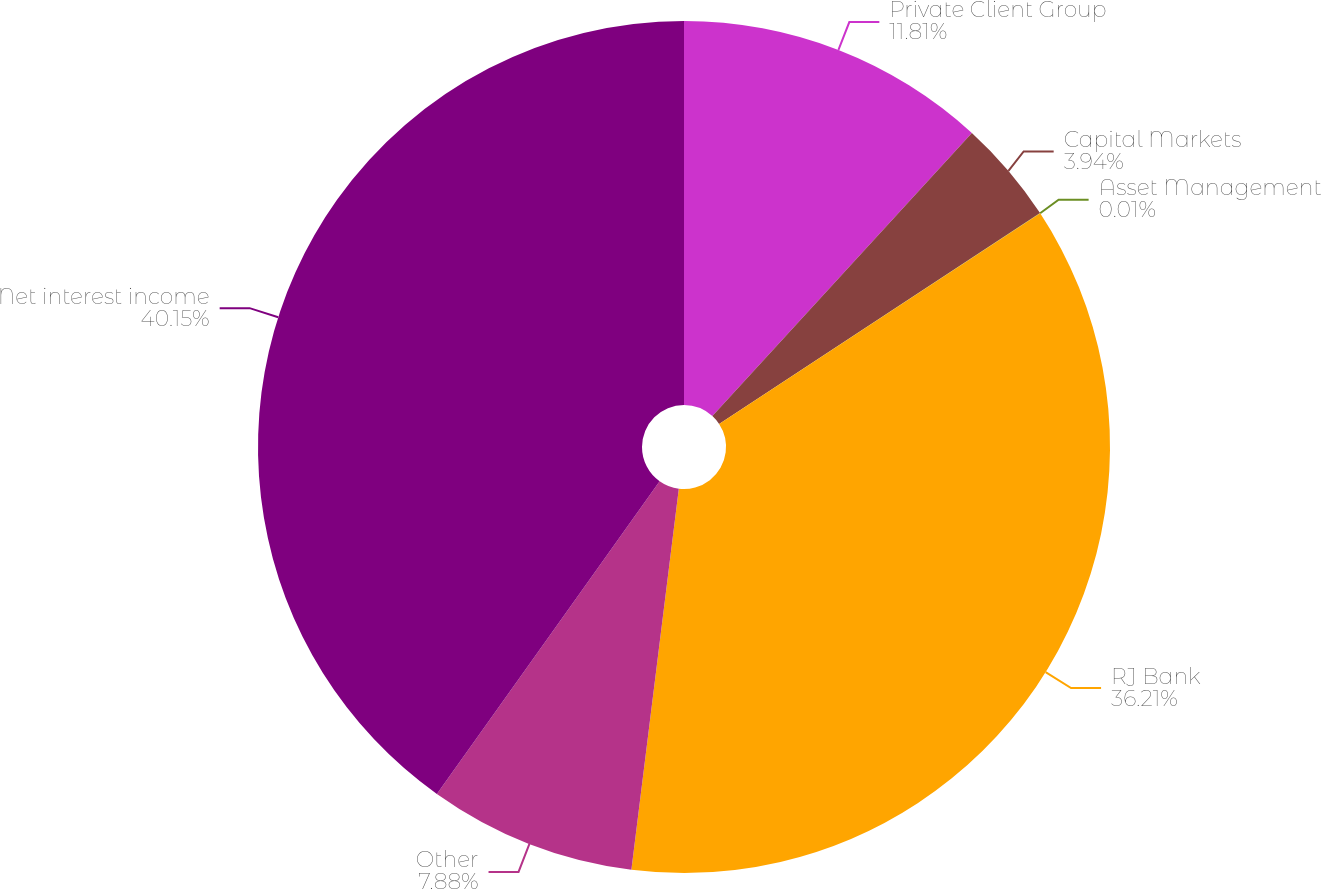Convert chart. <chart><loc_0><loc_0><loc_500><loc_500><pie_chart><fcel>Private Client Group<fcel>Capital Markets<fcel>Asset Management<fcel>RJ Bank<fcel>Other<fcel>Net interest income<nl><fcel>11.81%<fcel>3.94%<fcel>0.01%<fcel>36.21%<fcel>7.88%<fcel>40.15%<nl></chart> 